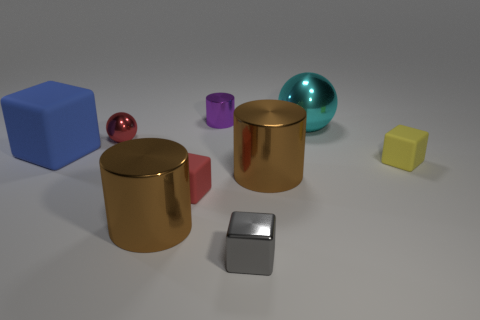Subtract all tiny blocks. How many blocks are left? 1 Subtract 1 cylinders. How many cylinders are left? 2 Subtract all purple cubes. Subtract all gray cylinders. How many cubes are left? 4 Subtract all balls. How many objects are left? 7 Add 2 tiny gray metallic objects. How many tiny gray metallic objects are left? 3 Add 4 cyan objects. How many cyan objects exist? 5 Subtract 0 yellow cylinders. How many objects are left? 9 Subtract all yellow blocks. Subtract all large cyan objects. How many objects are left? 7 